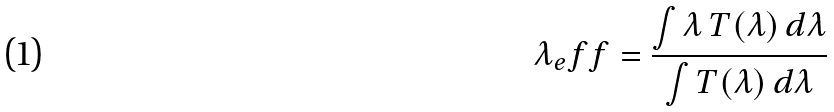Convert formula to latex. <formula><loc_0><loc_0><loc_500><loc_500>\lambda _ { e } f f = \frac { \int \lambda \, T ( \lambda ) \, d \lambda } { \int T ( \lambda ) \, d \lambda }</formula> 